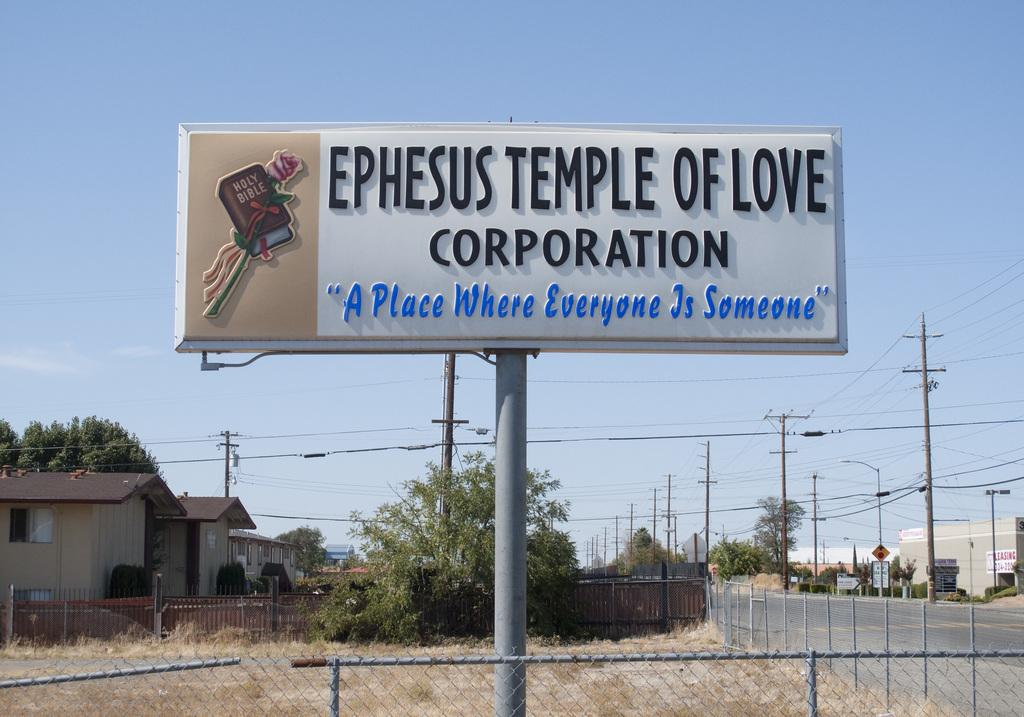Provide a one-sentence caption for the provided image. a big public billboard sign stating EPHESUS TEMPLE OF LOVE CORPORATION "A Place Where Everyone Is Someone" with a bible picture. 